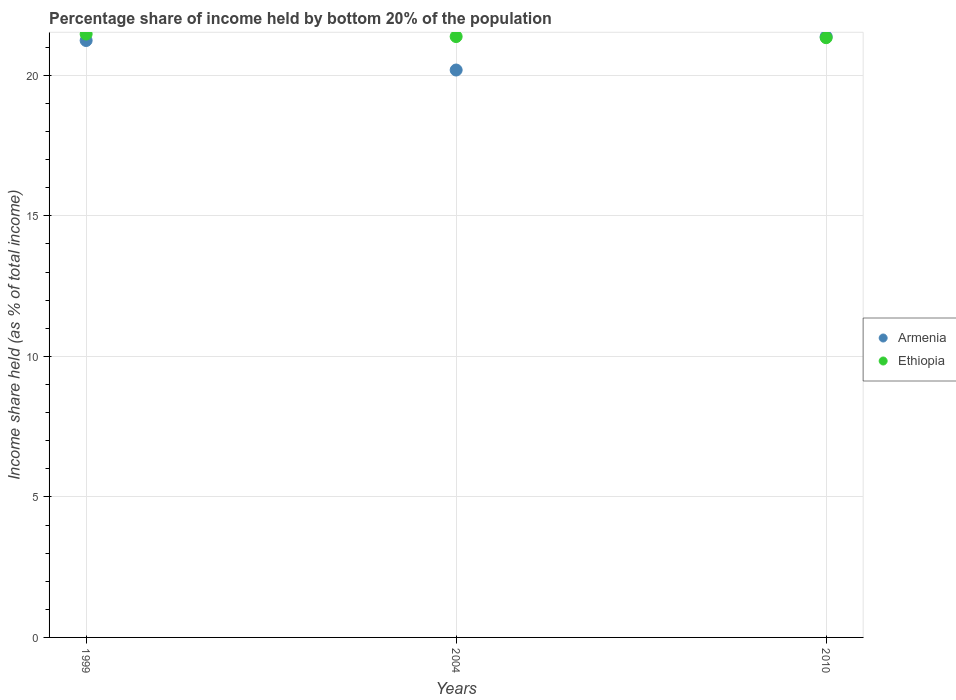How many different coloured dotlines are there?
Provide a succinct answer. 2. Is the number of dotlines equal to the number of legend labels?
Your answer should be very brief. Yes. What is the share of income held by bottom 20% of the population in Ethiopia in 2010?
Your response must be concise. 21.34. Across all years, what is the maximum share of income held by bottom 20% of the population in Ethiopia?
Offer a terse response. 21.47. Across all years, what is the minimum share of income held by bottom 20% of the population in Ethiopia?
Give a very brief answer. 21.34. In which year was the share of income held by bottom 20% of the population in Armenia maximum?
Your answer should be very brief. 2010. In which year was the share of income held by bottom 20% of the population in Ethiopia minimum?
Keep it short and to the point. 2010. What is the total share of income held by bottom 20% of the population in Ethiopia in the graph?
Give a very brief answer. 64.19. What is the difference between the share of income held by bottom 20% of the population in Armenia in 2004 and that in 2010?
Ensure brevity in your answer.  -1.19. What is the difference between the share of income held by bottom 20% of the population in Armenia in 1999 and the share of income held by bottom 20% of the population in Ethiopia in 2010?
Provide a succinct answer. -0.1. What is the average share of income held by bottom 20% of the population in Ethiopia per year?
Provide a succinct answer. 21.4. In the year 2004, what is the difference between the share of income held by bottom 20% of the population in Armenia and share of income held by bottom 20% of the population in Ethiopia?
Provide a short and direct response. -1.19. In how many years, is the share of income held by bottom 20% of the population in Armenia greater than 9 %?
Give a very brief answer. 3. What is the ratio of the share of income held by bottom 20% of the population in Armenia in 1999 to that in 2004?
Offer a terse response. 1.05. Is the difference between the share of income held by bottom 20% of the population in Armenia in 1999 and 2004 greater than the difference between the share of income held by bottom 20% of the population in Ethiopia in 1999 and 2004?
Ensure brevity in your answer.  Yes. What is the difference between the highest and the second highest share of income held by bottom 20% of the population in Ethiopia?
Make the answer very short. 0.09. What is the difference between the highest and the lowest share of income held by bottom 20% of the population in Ethiopia?
Make the answer very short. 0.13. Is the sum of the share of income held by bottom 20% of the population in Armenia in 1999 and 2004 greater than the maximum share of income held by bottom 20% of the population in Ethiopia across all years?
Provide a short and direct response. Yes. Does the share of income held by bottom 20% of the population in Ethiopia monotonically increase over the years?
Offer a terse response. No. Is the share of income held by bottom 20% of the population in Armenia strictly greater than the share of income held by bottom 20% of the population in Ethiopia over the years?
Provide a short and direct response. No. How many years are there in the graph?
Your answer should be compact. 3. What is the difference between two consecutive major ticks on the Y-axis?
Offer a terse response. 5. Does the graph contain any zero values?
Provide a succinct answer. No. How are the legend labels stacked?
Your answer should be very brief. Vertical. What is the title of the graph?
Make the answer very short. Percentage share of income held by bottom 20% of the population. What is the label or title of the X-axis?
Your answer should be compact. Years. What is the label or title of the Y-axis?
Your answer should be compact. Income share held (as % of total income). What is the Income share held (as % of total income) in Armenia in 1999?
Provide a succinct answer. 21.24. What is the Income share held (as % of total income) of Ethiopia in 1999?
Offer a terse response. 21.47. What is the Income share held (as % of total income) in Armenia in 2004?
Offer a terse response. 20.19. What is the Income share held (as % of total income) of Ethiopia in 2004?
Provide a succinct answer. 21.38. What is the Income share held (as % of total income) in Armenia in 2010?
Your response must be concise. 21.38. What is the Income share held (as % of total income) of Ethiopia in 2010?
Provide a succinct answer. 21.34. Across all years, what is the maximum Income share held (as % of total income) in Armenia?
Keep it short and to the point. 21.38. Across all years, what is the maximum Income share held (as % of total income) in Ethiopia?
Your answer should be very brief. 21.47. Across all years, what is the minimum Income share held (as % of total income) of Armenia?
Keep it short and to the point. 20.19. Across all years, what is the minimum Income share held (as % of total income) of Ethiopia?
Ensure brevity in your answer.  21.34. What is the total Income share held (as % of total income) in Armenia in the graph?
Give a very brief answer. 62.81. What is the total Income share held (as % of total income) of Ethiopia in the graph?
Give a very brief answer. 64.19. What is the difference between the Income share held (as % of total income) in Ethiopia in 1999 and that in 2004?
Your answer should be very brief. 0.09. What is the difference between the Income share held (as % of total income) in Armenia in 1999 and that in 2010?
Offer a terse response. -0.14. What is the difference between the Income share held (as % of total income) of Ethiopia in 1999 and that in 2010?
Your answer should be compact. 0.13. What is the difference between the Income share held (as % of total income) of Armenia in 2004 and that in 2010?
Your answer should be compact. -1.19. What is the difference between the Income share held (as % of total income) of Armenia in 1999 and the Income share held (as % of total income) of Ethiopia in 2004?
Your answer should be compact. -0.14. What is the difference between the Income share held (as % of total income) of Armenia in 1999 and the Income share held (as % of total income) of Ethiopia in 2010?
Make the answer very short. -0.1. What is the difference between the Income share held (as % of total income) in Armenia in 2004 and the Income share held (as % of total income) in Ethiopia in 2010?
Provide a short and direct response. -1.15. What is the average Income share held (as % of total income) in Armenia per year?
Offer a very short reply. 20.94. What is the average Income share held (as % of total income) of Ethiopia per year?
Your response must be concise. 21.4. In the year 1999, what is the difference between the Income share held (as % of total income) in Armenia and Income share held (as % of total income) in Ethiopia?
Provide a short and direct response. -0.23. In the year 2004, what is the difference between the Income share held (as % of total income) in Armenia and Income share held (as % of total income) in Ethiopia?
Keep it short and to the point. -1.19. What is the ratio of the Income share held (as % of total income) in Armenia in 1999 to that in 2004?
Your answer should be very brief. 1.05. What is the ratio of the Income share held (as % of total income) of Armenia in 1999 to that in 2010?
Offer a very short reply. 0.99. What is the ratio of the Income share held (as % of total income) in Ethiopia in 1999 to that in 2010?
Your response must be concise. 1.01. What is the ratio of the Income share held (as % of total income) of Armenia in 2004 to that in 2010?
Give a very brief answer. 0.94. What is the difference between the highest and the second highest Income share held (as % of total income) of Armenia?
Keep it short and to the point. 0.14. What is the difference between the highest and the second highest Income share held (as % of total income) of Ethiopia?
Your answer should be very brief. 0.09. What is the difference between the highest and the lowest Income share held (as % of total income) of Armenia?
Provide a succinct answer. 1.19. What is the difference between the highest and the lowest Income share held (as % of total income) in Ethiopia?
Give a very brief answer. 0.13. 